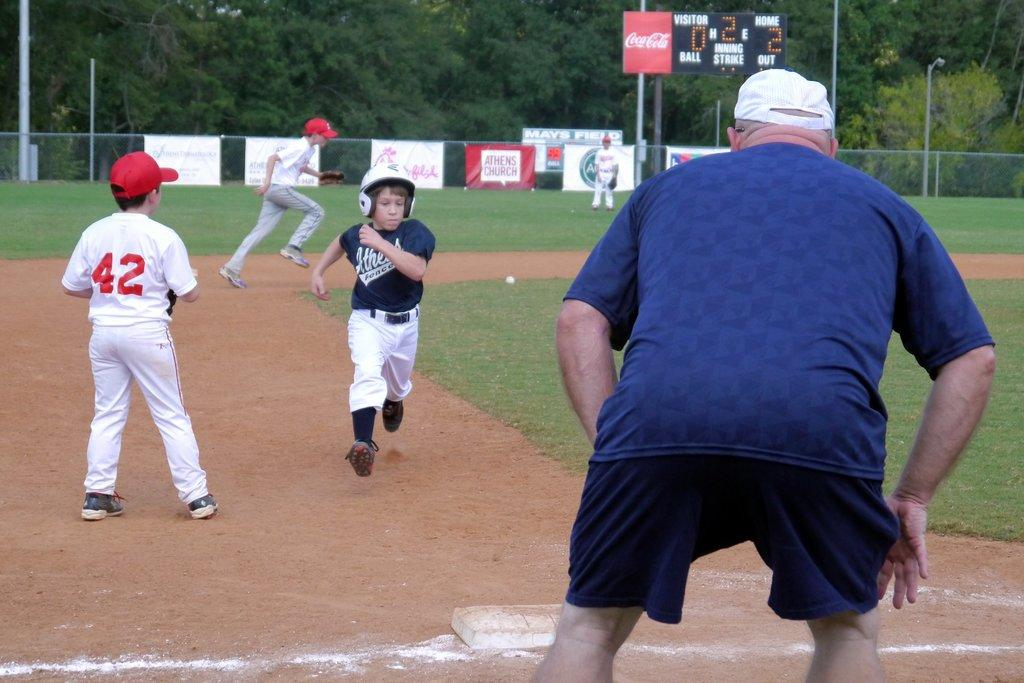<image>
Render a clear and concise summary of the photo. The player with 42 on his back watches a player from the other team as he runs. 